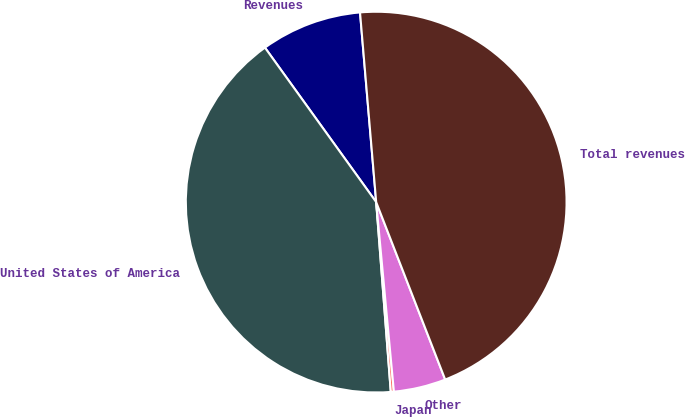Convert chart. <chart><loc_0><loc_0><loc_500><loc_500><pie_chart><fcel>Revenues<fcel>United States of America<fcel>Japan<fcel>Other<fcel>Total revenues<nl><fcel>8.58%<fcel>41.29%<fcel>0.26%<fcel>4.42%<fcel>45.45%<nl></chart> 